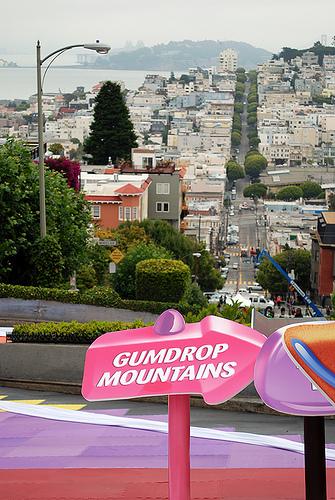Why isn't the street light on?
Give a very brief answer. Daytime. What is in the horizon?
Quick response, please. Mountain. Is this candyland?
Quick response, please. Yes. 